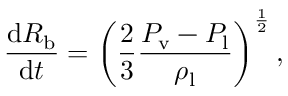<formula> <loc_0><loc_0><loc_500><loc_500>\frac { \mathrm d R _ { b } } { \mathrm d t } = \left ( \frac { 2 } { 3 } \frac { P _ { v } - P _ { l } } { \rho _ { l } } \right ) ^ { \frac { 1 } { 2 } } ,</formula> 